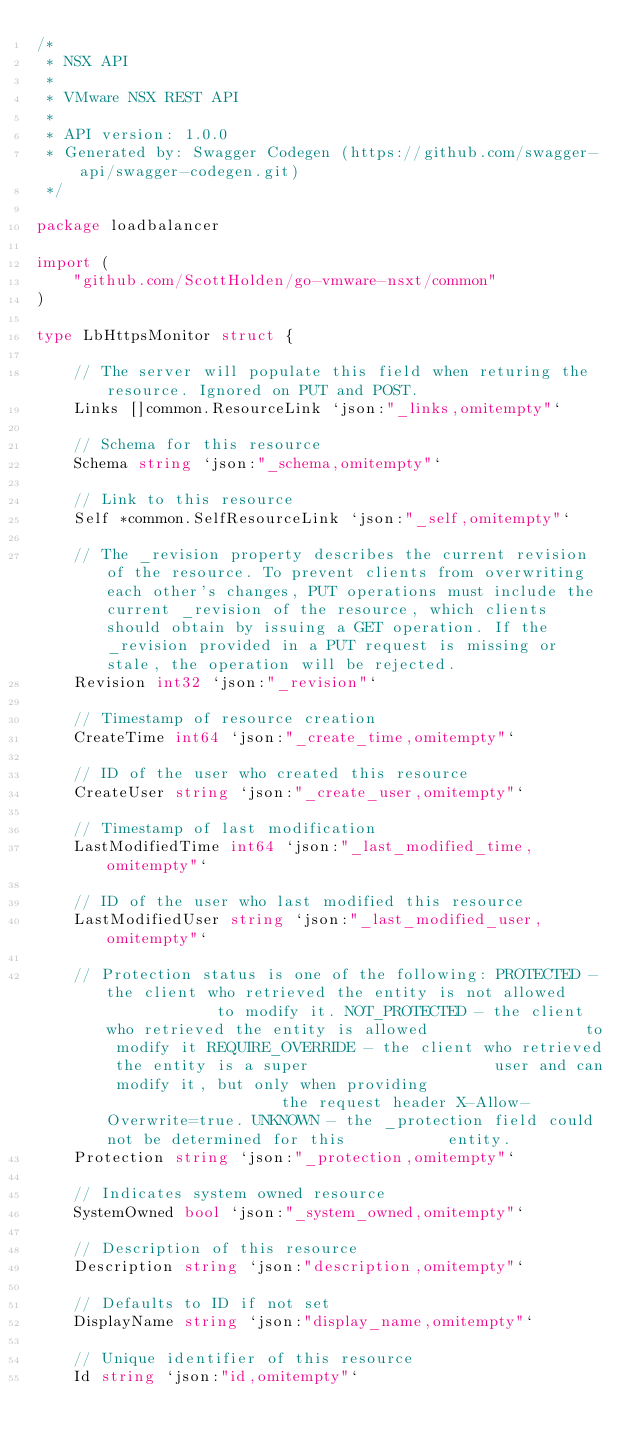<code> <loc_0><loc_0><loc_500><loc_500><_Go_>/*
 * NSX API
 *
 * VMware NSX REST API
 *
 * API version: 1.0.0
 * Generated by: Swagger Codegen (https://github.com/swagger-api/swagger-codegen.git)
 */

package loadbalancer

import (
	"github.com/ScottHolden/go-vmware-nsxt/common"
)

type LbHttpsMonitor struct {

	// The server will populate this field when returing the resource. Ignored on PUT and POST.
	Links []common.ResourceLink `json:"_links,omitempty"`

	// Schema for this resource
	Schema string `json:"_schema,omitempty"`

	// Link to this resource
	Self *common.SelfResourceLink `json:"_self,omitempty"`

	// The _revision property describes the current revision of the resource. To prevent clients from overwriting each other's changes, PUT operations must include the current _revision of the resource, which clients should obtain by issuing a GET operation. If the _revision provided in a PUT request is missing or stale, the operation will be rejected.
	Revision int32 `json:"_revision"`

	// Timestamp of resource creation
	CreateTime int64 `json:"_create_time,omitempty"`

	// ID of the user who created this resource
	CreateUser string `json:"_create_user,omitempty"`

	// Timestamp of last modification
	LastModifiedTime int64 `json:"_last_modified_time,omitempty"`

	// ID of the user who last modified this resource
	LastModifiedUser string `json:"_last_modified_user,omitempty"`

	// Protection status is one of the following: PROTECTED - the client who retrieved the entity is not allowed             to modify it. NOT_PROTECTED - the client who retrieved the entity is allowed                 to modify it REQUIRE_OVERRIDE - the client who retrieved the entity is a super                    user and can modify it, but only when providing                    the request header X-Allow-Overwrite=true. UNKNOWN - the _protection field could not be determined for this           entity.
	Protection string `json:"_protection,omitempty"`

	// Indicates system owned resource
	SystemOwned bool `json:"_system_owned,omitempty"`

	// Description of this resource
	Description string `json:"description,omitempty"`

	// Defaults to ID if not set
	DisplayName string `json:"display_name,omitempty"`

	// Unique identifier of this resource
	Id string `json:"id,omitempty"`
</code> 